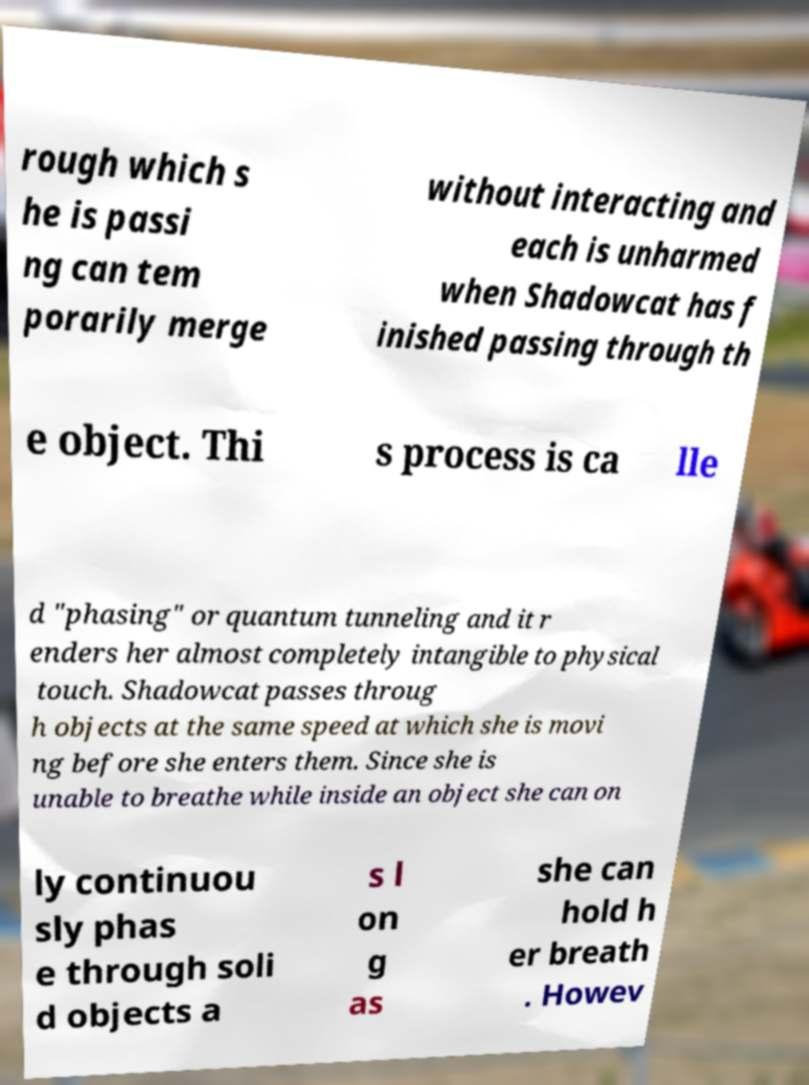Please identify and transcribe the text found in this image. rough which s he is passi ng can tem porarily merge without interacting and each is unharmed when Shadowcat has f inished passing through th e object. Thi s process is ca lle d "phasing" or quantum tunneling and it r enders her almost completely intangible to physical touch. Shadowcat passes throug h objects at the same speed at which she is movi ng before she enters them. Since she is unable to breathe while inside an object she can on ly continuou sly phas e through soli d objects a s l on g as she can hold h er breath . Howev 